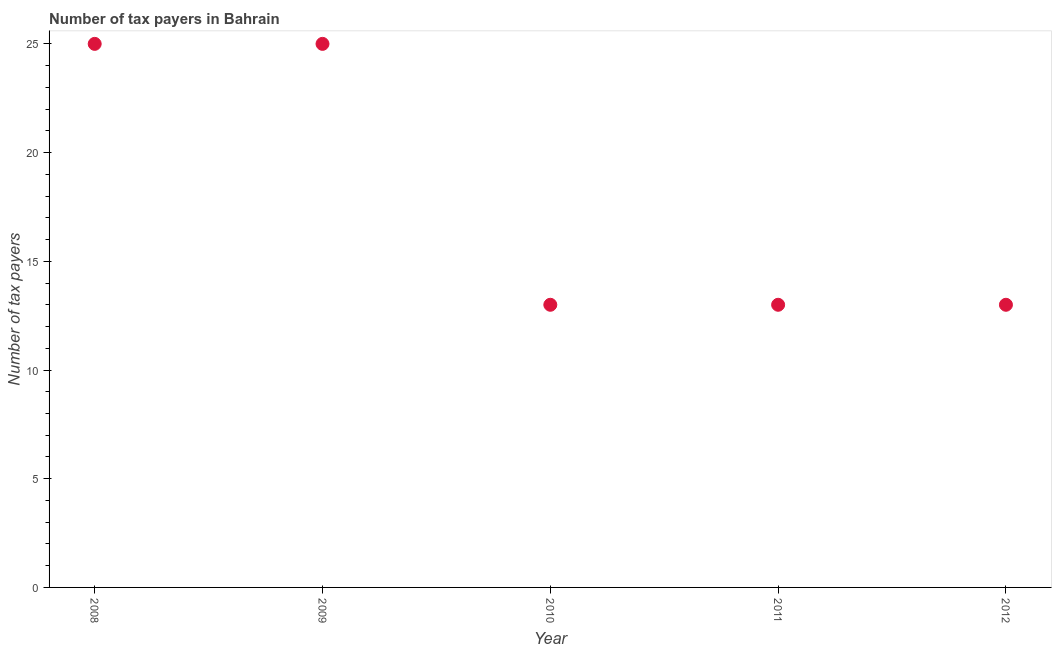What is the number of tax payers in 2010?
Provide a short and direct response. 13. Across all years, what is the maximum number of tax payers?
Your answer should be very brief. 25. Across all years, what is the minimum number of tax payers?
Keep it short and to the point. 13. In which year was the number of tax payers maximum?
Offer a very short reply. 2008. In which year was the number of tax payers minimum?
Offer a very short reply. 2010. What is the sum of the number of tax payers?
Your answer should be very brief. 89. What is the difference between the number of tax payers in 2010 and 2011?
Your answer should be compact. 0. What is the average number of tax payers per year?
Provide a short and direct response. 17.8. What is the median number of tax payers?
Make the answer very short. 13. What is the ratio of the number of tax payers in 2008 to that in 2012?
Make the answer very short. 1.92. Is the sum of the number of tax payers in 2009 and 2011 greater than the maximum number of tax payers across all years?
Your response must be concise. Yes. What is the difference between the highest and the lowest number of tax payers?
Provide a succinct answer. 12. In how many years, is the number of tax payers greater than the average number of tax payers taken over all years?
Give a very brief answer. 2. How many dotlines are there?
Offer a very short reply. 1. How many years are there in the graph?
Provide a short and direct response. 5. What is the difference between two consecutive major ticks on the Y-axis?
Offer a terse response. 5. Are the values on the major ticks of Y-axis written in scientific E-notation?
Ensure brevity in your answer.  No. What is the title of the graph?
Provide a succinct answer. Number of tax payers in Bahrain. What is the label or title of the Y-axis?
Your answer should be very brief. Number of tax payers. What is the Number of tax payers in 2008?
Give a very brief answer. 25. What is the Number of tax payers in 2009?
Ensure brevity in your answer.  25. What is the Number of tax payers in 2011?
Your answer should be very brief. 13. What is the Number of tax payers in 2012?
Offer a very short reply. 13. What is the difference between the Number of tax payers in 2008 and 2009?
Give a very brief answer. 0. What is the difference between the Number of tax payers in 2008 and 2010?
Your answer should be very brief. 12. What is the difference between the Number of tax payers in 2008 and 2011?
Provide a short and direct response. 12. What is the difference between the Number of tax payers in 2010 and 2011?
Your answer should be very brief. 0. What is the difference between the Number of tax payers in 2011 and 2012?
Your response must be concise. 0. What is the ratio of the Number of tax payers in 2008 to that in 2010?
Make the answer very short. 1.92. What is the ratio of the Number of tax payers in 2008 to that in 2011?
Offer a very short reply. 1.92. What is the ratio of the Number of tax payers in 2008 to that in 2012?
Make the answer very short. 1.92. What is the ratio of the Number of tax payers in 2009 to that in 2010?
Provide a short and direct response. 1.92. What is the ratio of the Number of tax payers in 2009 to that in 2011?
Your answer should be very brief. 1.92. What is the ratio of the Number of tax payers in 2009 to that in 2012?
Make the answer very short. 1.92. What is the ratio of the Number of tax payers in 2010 to that in 2012?
Your answer should be compact. 1. What is the ratio of the Number of tax payers in 2011 to that in 2012?
Your response must be concise. 1. 